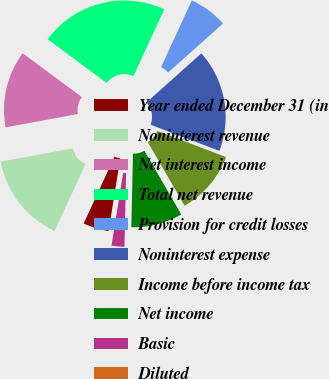Convert chart. <chart><loc_0><loc_0><loc_500><loc_500><pie_chart><fcel>Year ended December 31 (in<fcel>Noninterest revenue<fcel>Net interest income<fcel>Total net revenue<fcel>Provision for credit losses<fcel>Noninterest expense<fcel>Income before income tax<fcel>Net income<fcel>Basic<fcel>Diluted<nl><fcel>4.35%<fcel>15.22%<fcel>13.04%<fcel>21.74%<fcel>6.52%<fcel>17.39%<fcel>10.87%<fcel>8.7%<fcel>2.17%<fcel>0.0%<nl></chart> 